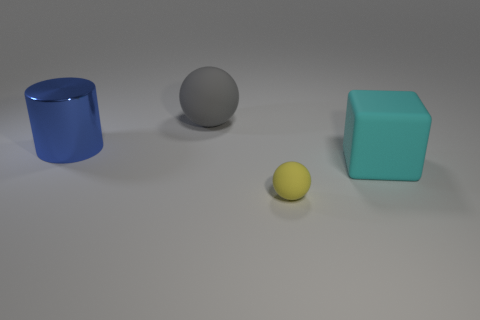What number of other things are there of the same shape as the gray rubber object? 1 